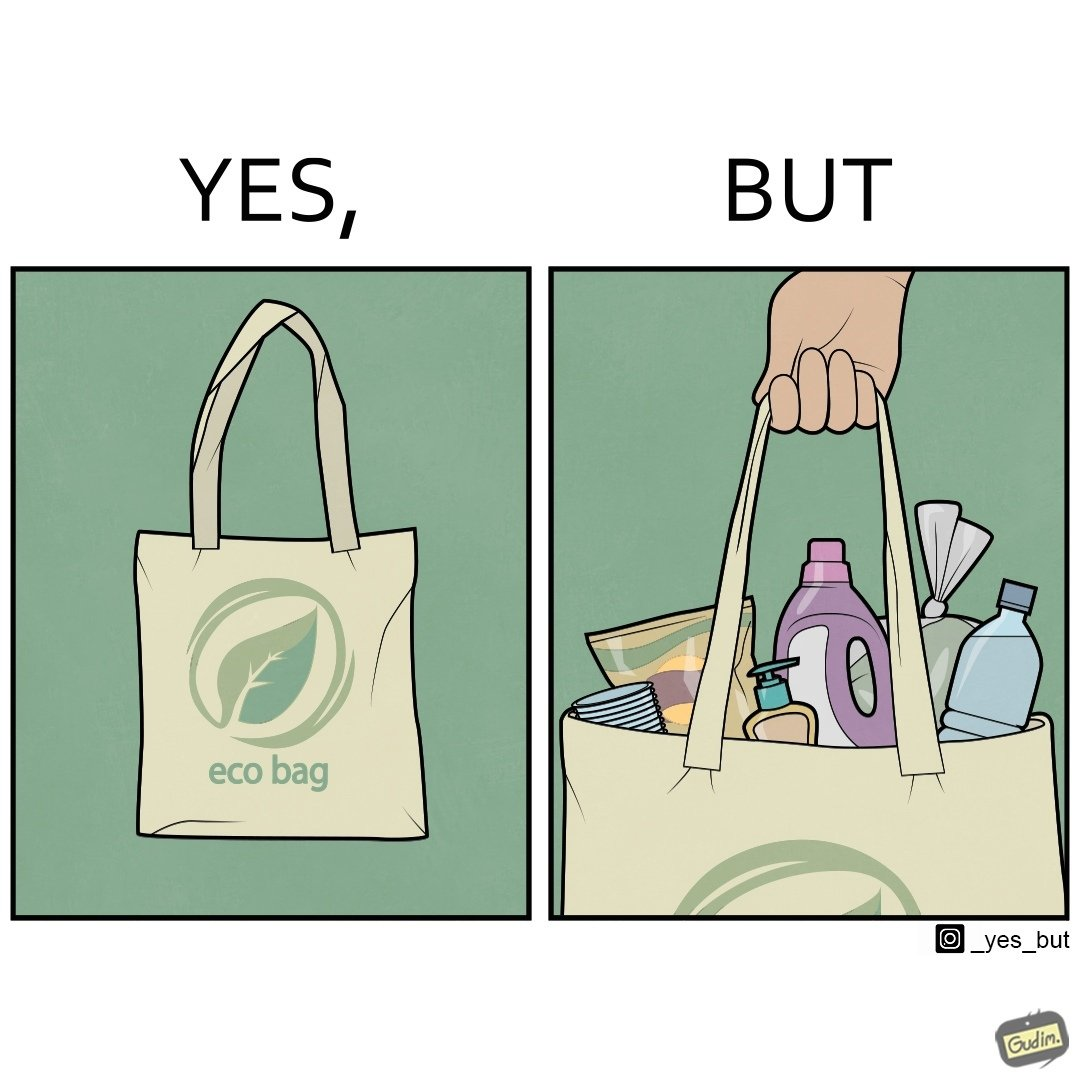Would you classify this image as satirical? Yes, this image is satirical. 